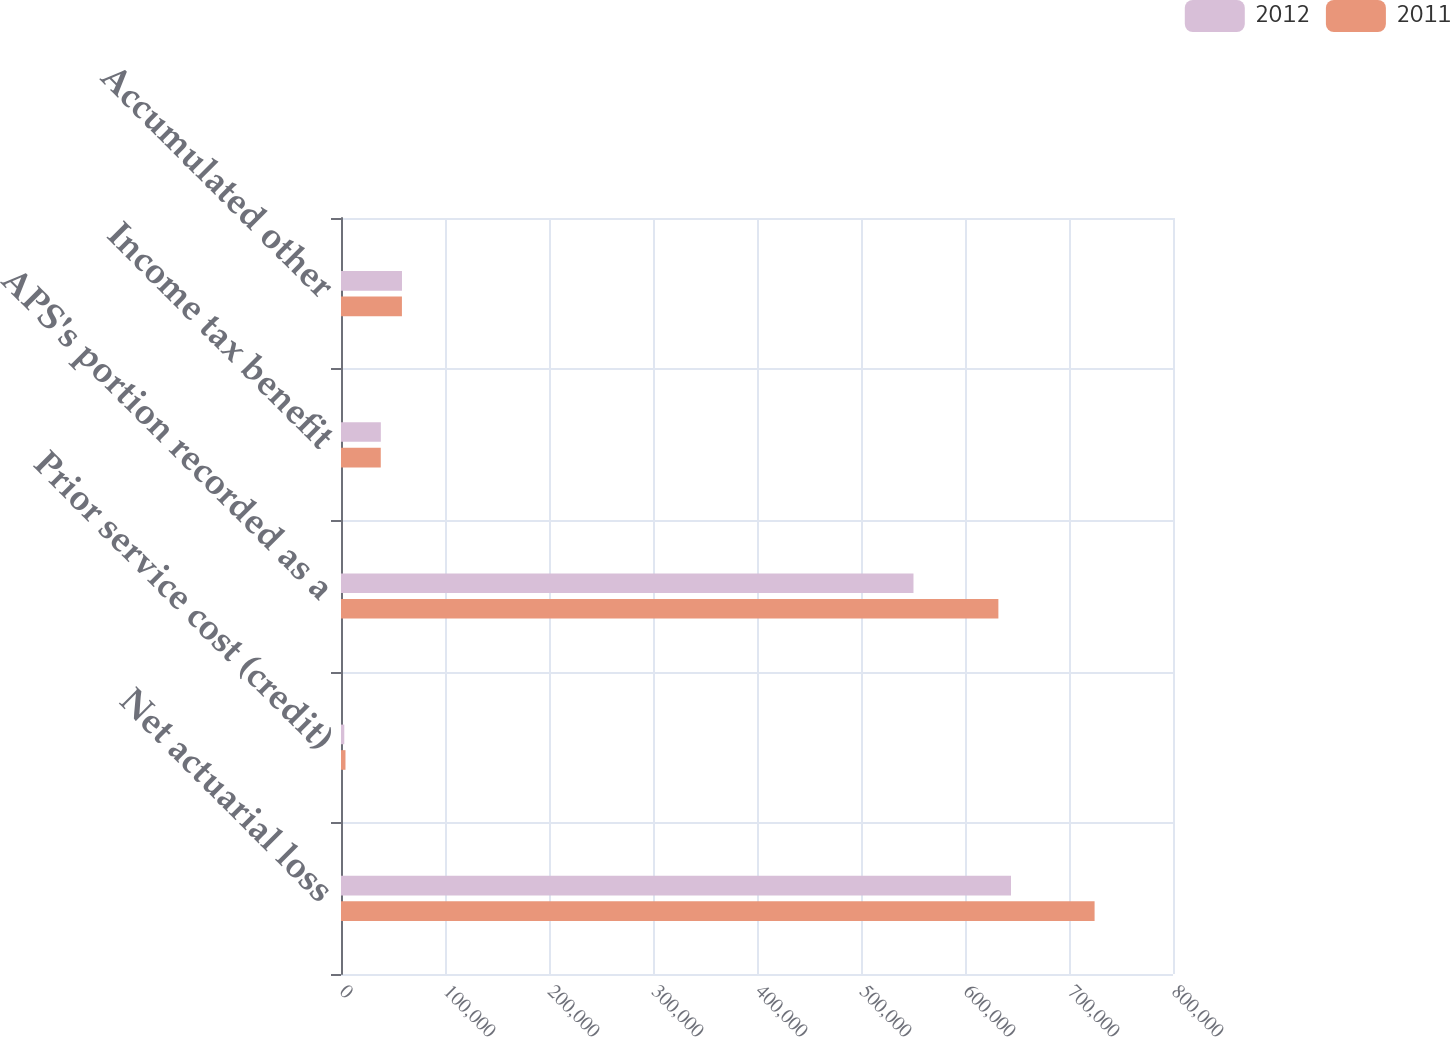Convert chart to OTSL. <chart><loc_0><loc_0><loc_500><loc_500><stacked_bar_chart><ecel><fcel>Net actuarial loss<fcel>Prior service cost (credit)<fcel>APS's portion recorded as a<fcel>Income tax benefit<fcel>Accumulated other<nl><fcel>2012<fcel>644239<fcel>3169<fcel>550471<fcel>38303<fcel>58634<nl><fcel>2011<fcel>724605<fcel>4312<fcel>632099<fcel>38243<fcel>58575<nl></chart> 